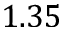<formula> <loc_0><loc_0><loc_500><loc_500>1 . 3 5</formula> 